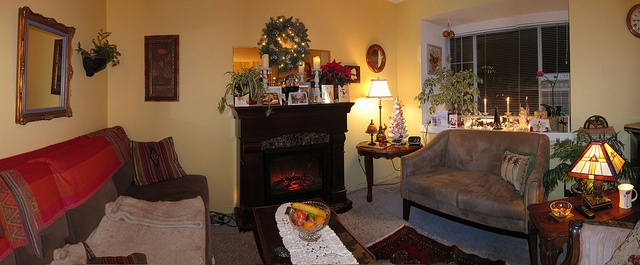Describe the objects in this image and their specific colors. I can see couch in tan, maroon, black, and gray tones, couch in tan, maroon, black, and gray tones, potted plant in tan, olive, gray, and black tones, potted plant in tan, black, gray, darkgreen, and maroon tones, and bowl in tan, red, gray, and maroon tones in this image. 